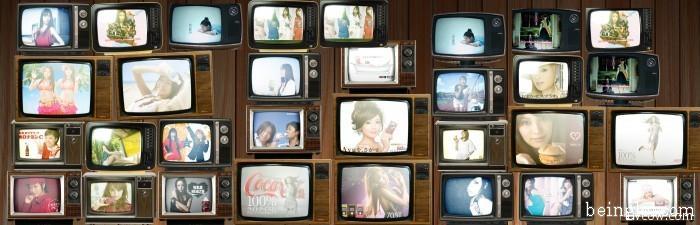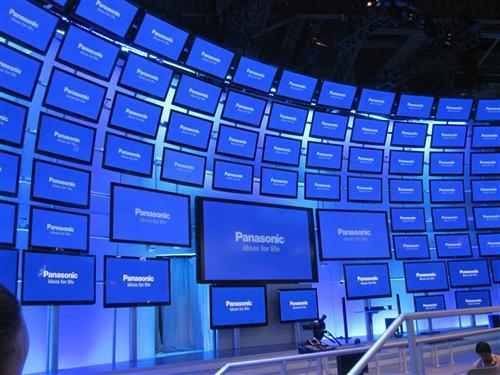The first image is the image on the left, the second image is the image on the right. Analyze the images presented: Is the assertion "An image shows at least four stacked rows that include non-flatscreen type TVs." valid? Answer yes or no. Yes. The first image is the image on the left, the second image is the image on the right. Examine the images to the left and right. Is the description "One of the images shows a group of at least ten vintage television sets." accurate? Answer yes or no. Yes. 